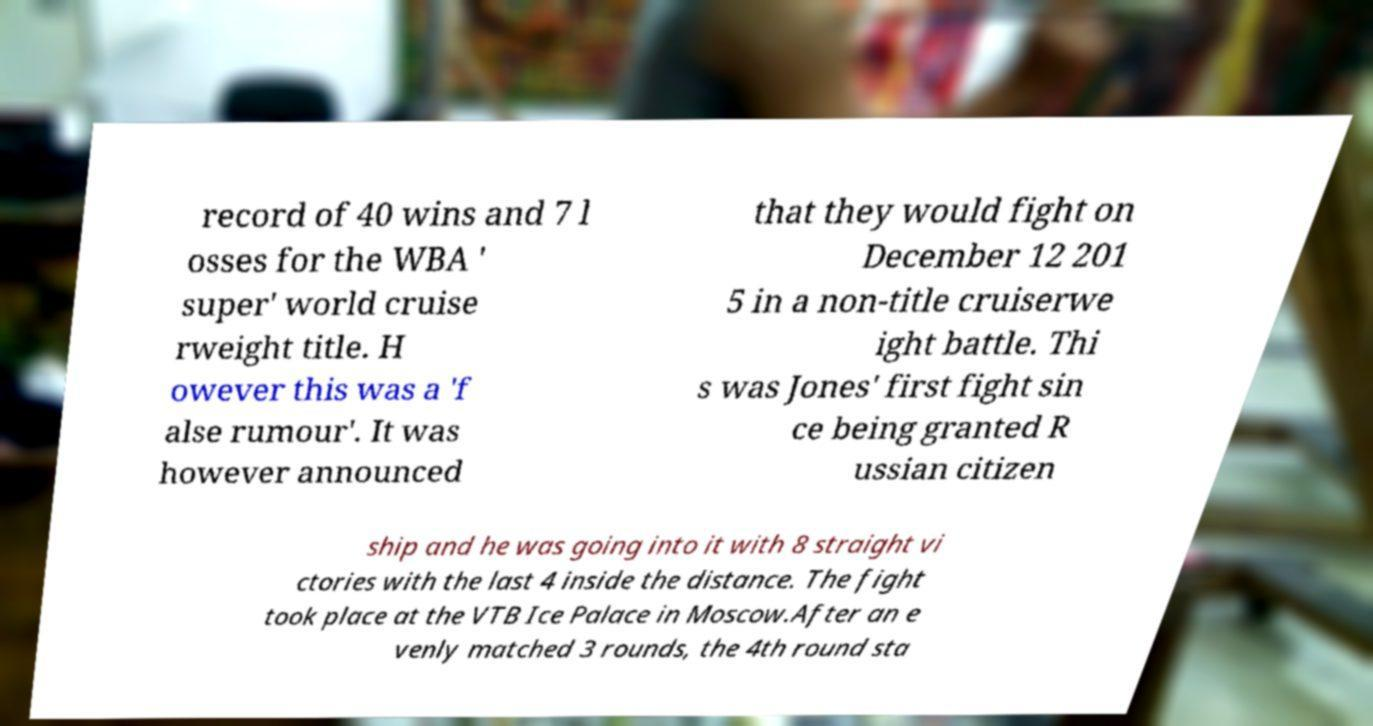What messages or text are displayed in this image? I need them in a readable, typed format. record of 40 wins and 7 l osses for the WBA ' super' world cruise rweight title. H owever this was a 'f alse rumour'. It was however announced that they would fight on December 12 201 5 in a non-title cruiserwe ight battle. Thi s was Jones' first fight sin ce being granted R ussian citizen ship and he was going into it with 8 straight vi ctories with the last 4 inside the distance. The fight took place at the VTB Ice Palace in Moscow.After an e venly matched 3 rounds, the 4th round sta 